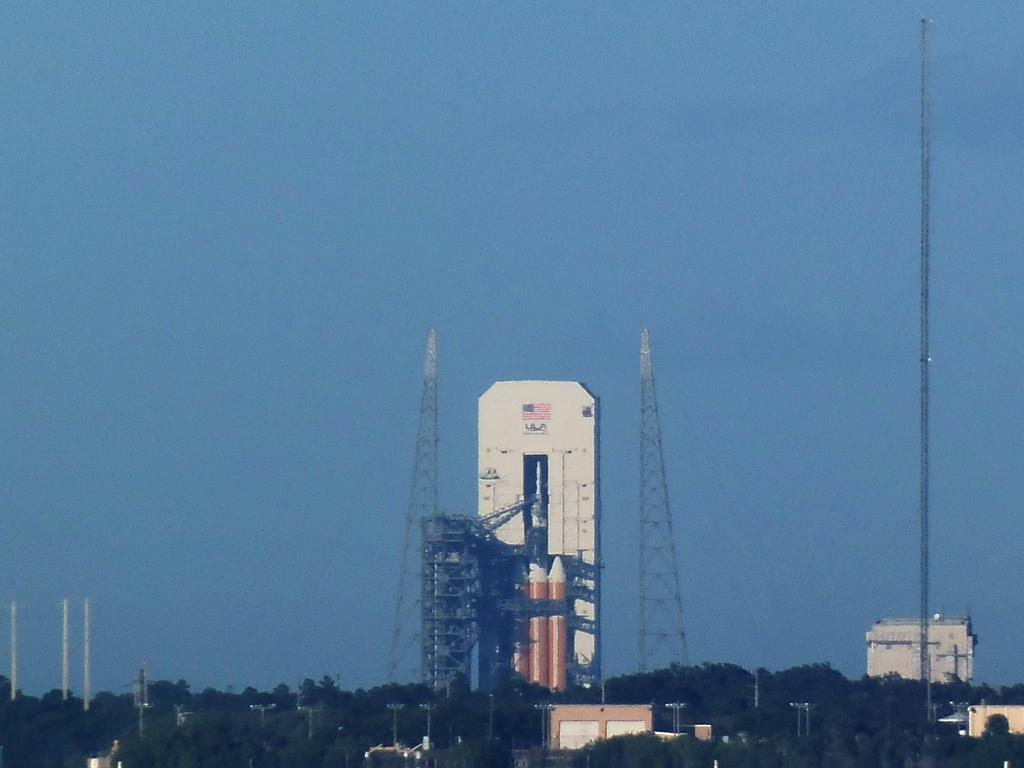What type of natural elements can be seen in the image? There are trees in the image. What type of man-made structures are present in the image? There are buildings, poles, and towers in the image. What is the primary focus of the image? The primary focus of the image is a rocket launcher and rockets. What part of the natural environment is visible in the image? The sky is visible in the image. What type of lunch is being served on the island in the image? There is no island or lunch present in the image. How much payment is required for the rocket launcher in the image? There is no indication of payment or cost associated with the rocket launcher in the image. 